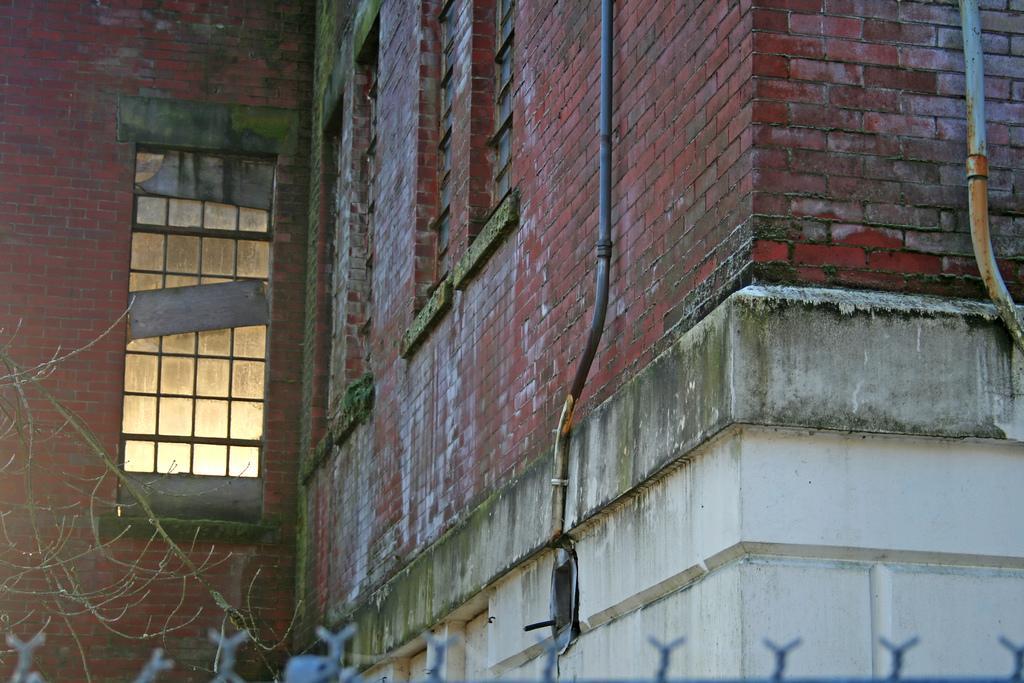Can you describe this image briefly? We can see building,pipes,windows and branches. 